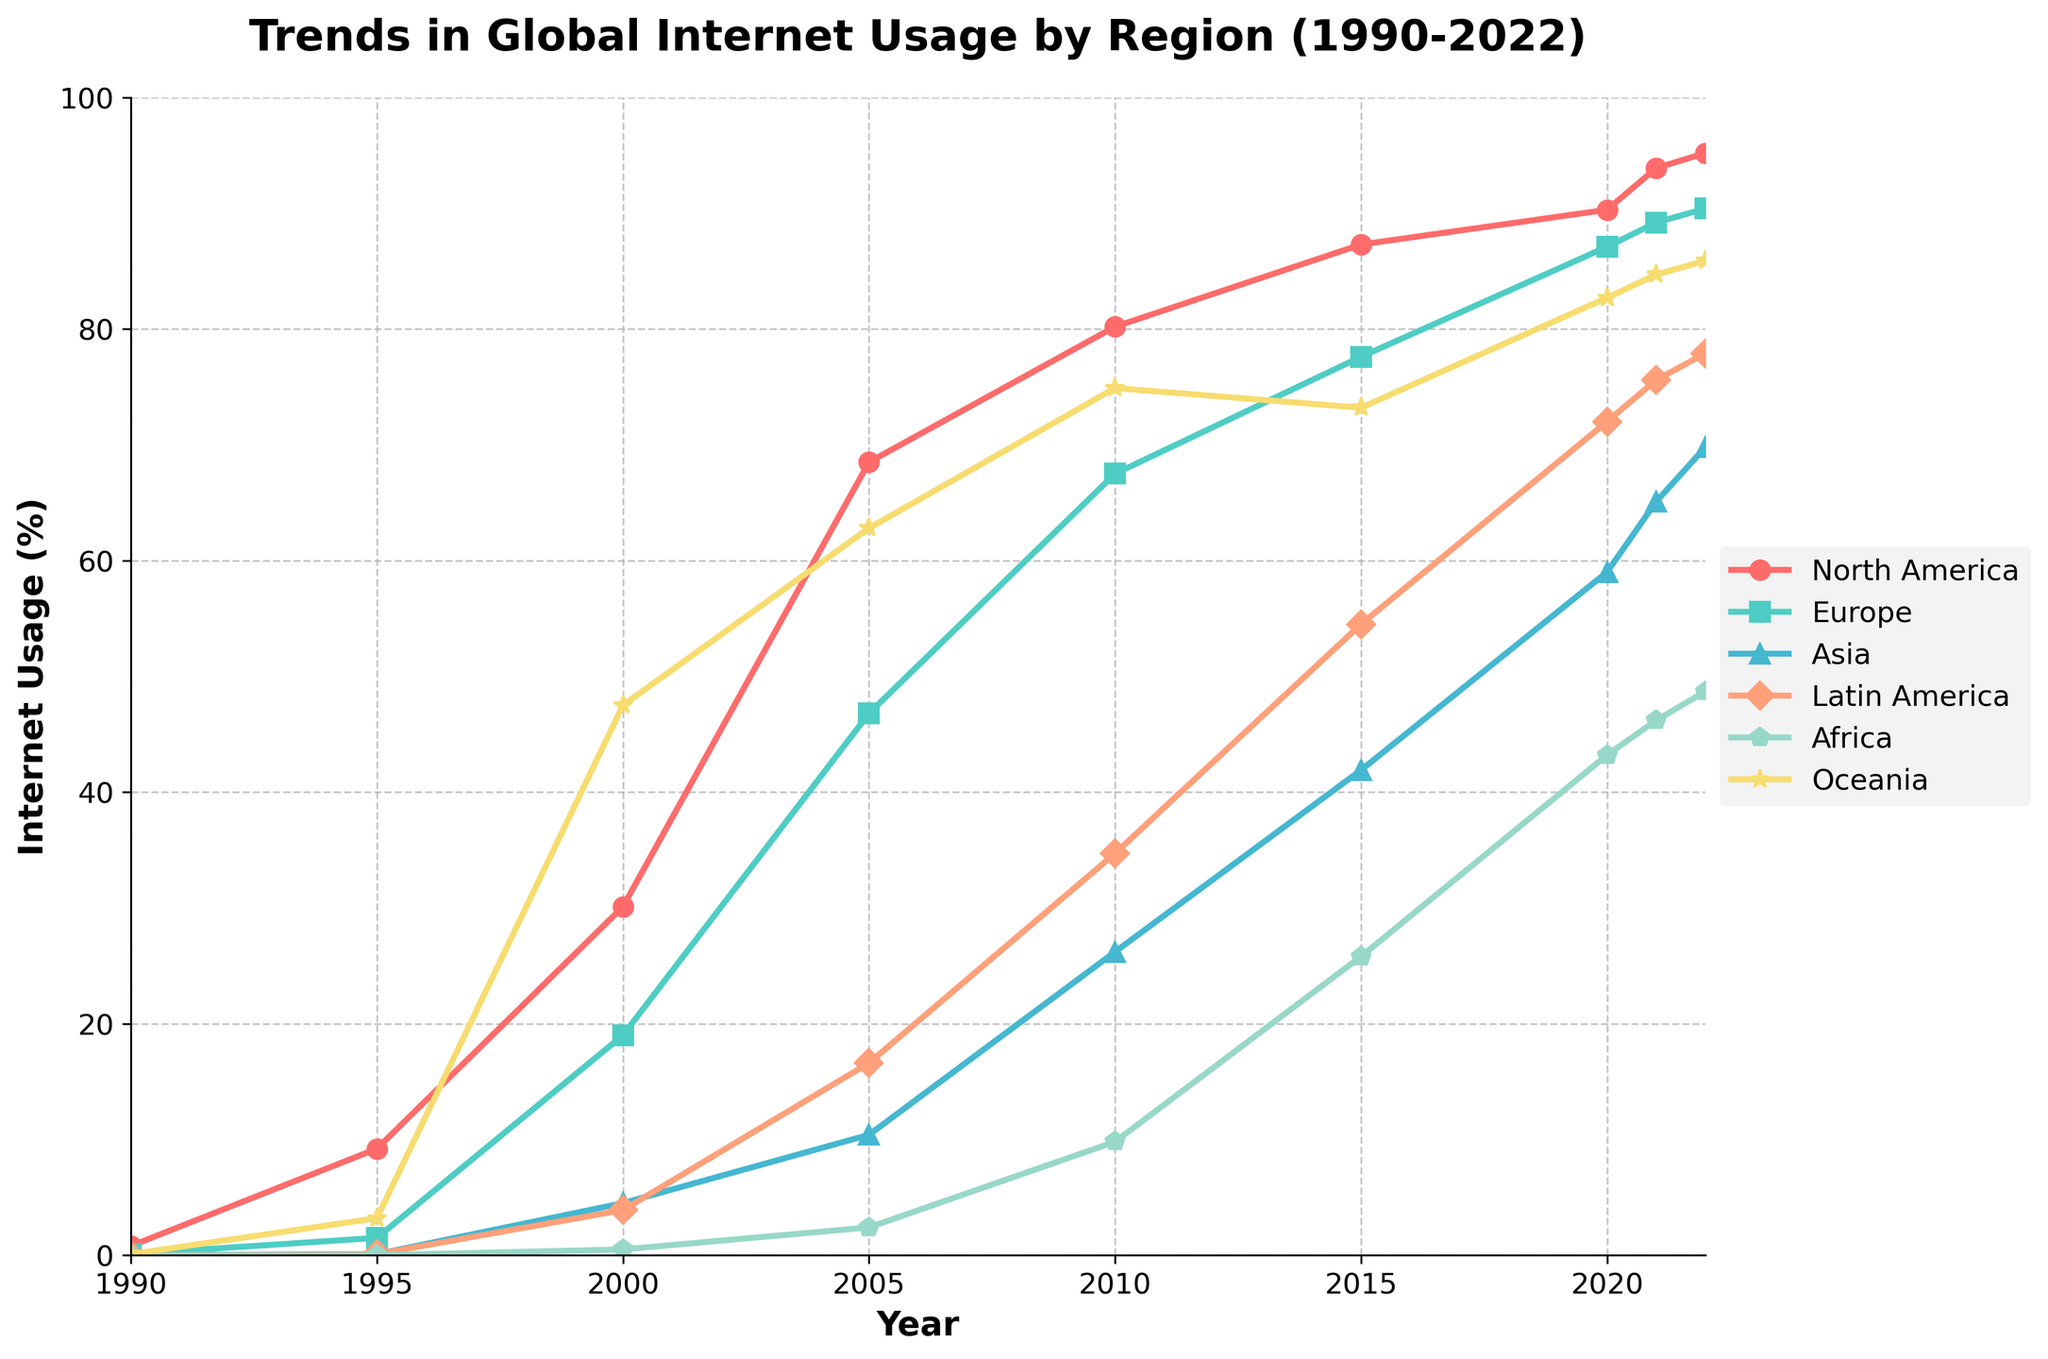What was the internet usage percentage in North America in 2000? Locate the point corresponding to the year 2000 on the x-axis and follow it until you reach the line representing North America. The y-axis value at that point is the usage percentage.
Answer: 30.1% Which region had the highest internet usage percentage in 2022? Find the values for all regions in the year 2022 and identify the highest value.
Answer: Oceania How much did internet usage in Asia increase from 2010 to 2020? Subtract the internet usage percentage in 2010 from that in 2020 for Asia. 59.0 (2020) - 26.2 (2010) = 32.8
Answer: 32.8% Which region experienced the largest increase in internet usage from 1990 to 2005? Calculate the difference between 2005 and 1990 internet usage percentages for all regions and compare them. The region with the maximum difference is the answer.
Answer: Oceania In which year did Europe surpass 50% internet usage? Locate Europe’s usage trend and find the first year where the y-axis value exceeds 50%.
Answer: 2005 Compare the internet usage between Latin America and Africa in 2015. Which region had a higher percentage, and by how much? Locate the values for Latin America and Africa in 2015, then find their difference. Latin America: 54.5%, Africa: 25.8%, Difference: 54.5 - 25.8 = 28.7
Answer: Latin America, 28.7% Between 1990 and 2022, which region consistently had the lowest internet usage percentage? Visually inspect the trends for all regions and identify which one maintained the lowest values throughout the years.
Answer: Africa How did Oceania's internet usage change from 1995 to 2000? Subtract the internet usage percentage in 1995 from that in 2000 for Oceania. 47.5 (2000) - 3.2 (1995) = 44.3
Answer: 44.3% Which regions show a steady increase in internet usage with no significant dips or flattening over the entire period? Visually analyze the trend lines and identify the regions that show a consistent upward trajectory.
Answer: North America, Europe, Asia, Latin America, Oceania 